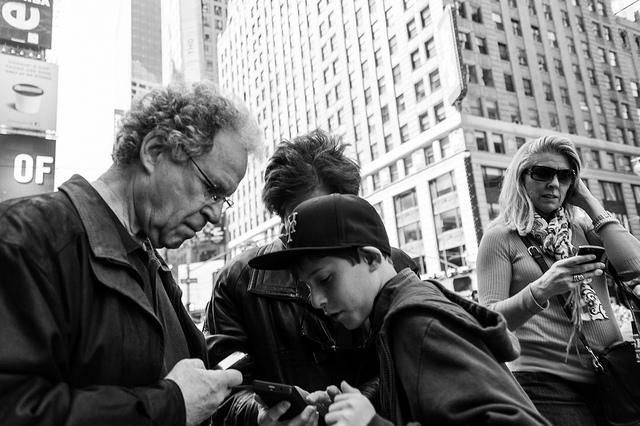What is the woman holding?
Keep it brief. Phone. What does the boy have on his head?
Concise answer only. Hat. Is the man wearing a watch?
Short answer required. No. How many people are shown?
Short answer required. 4. 